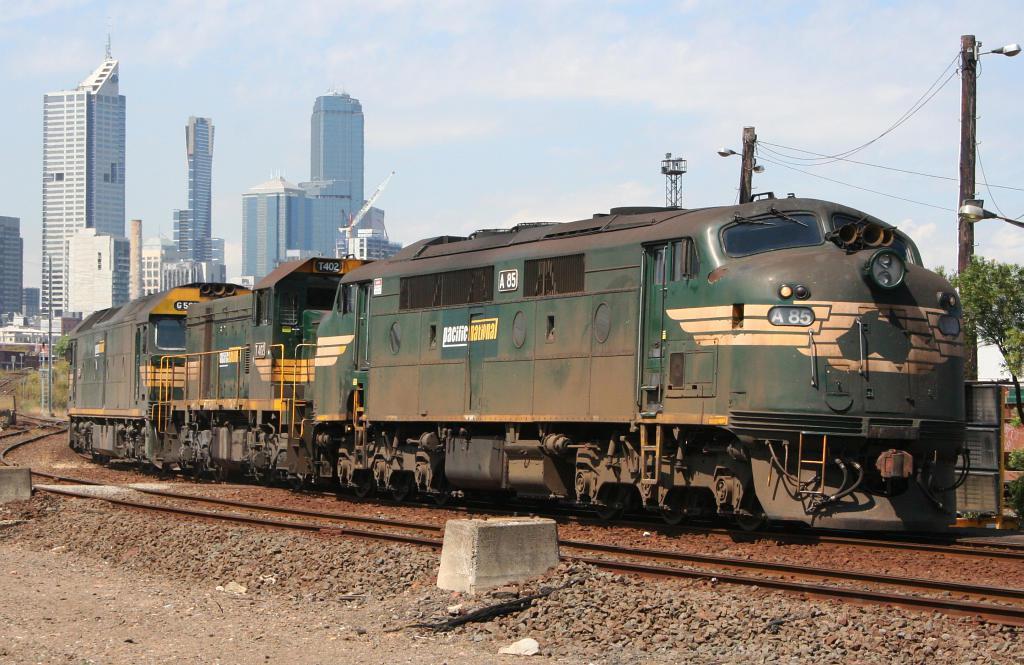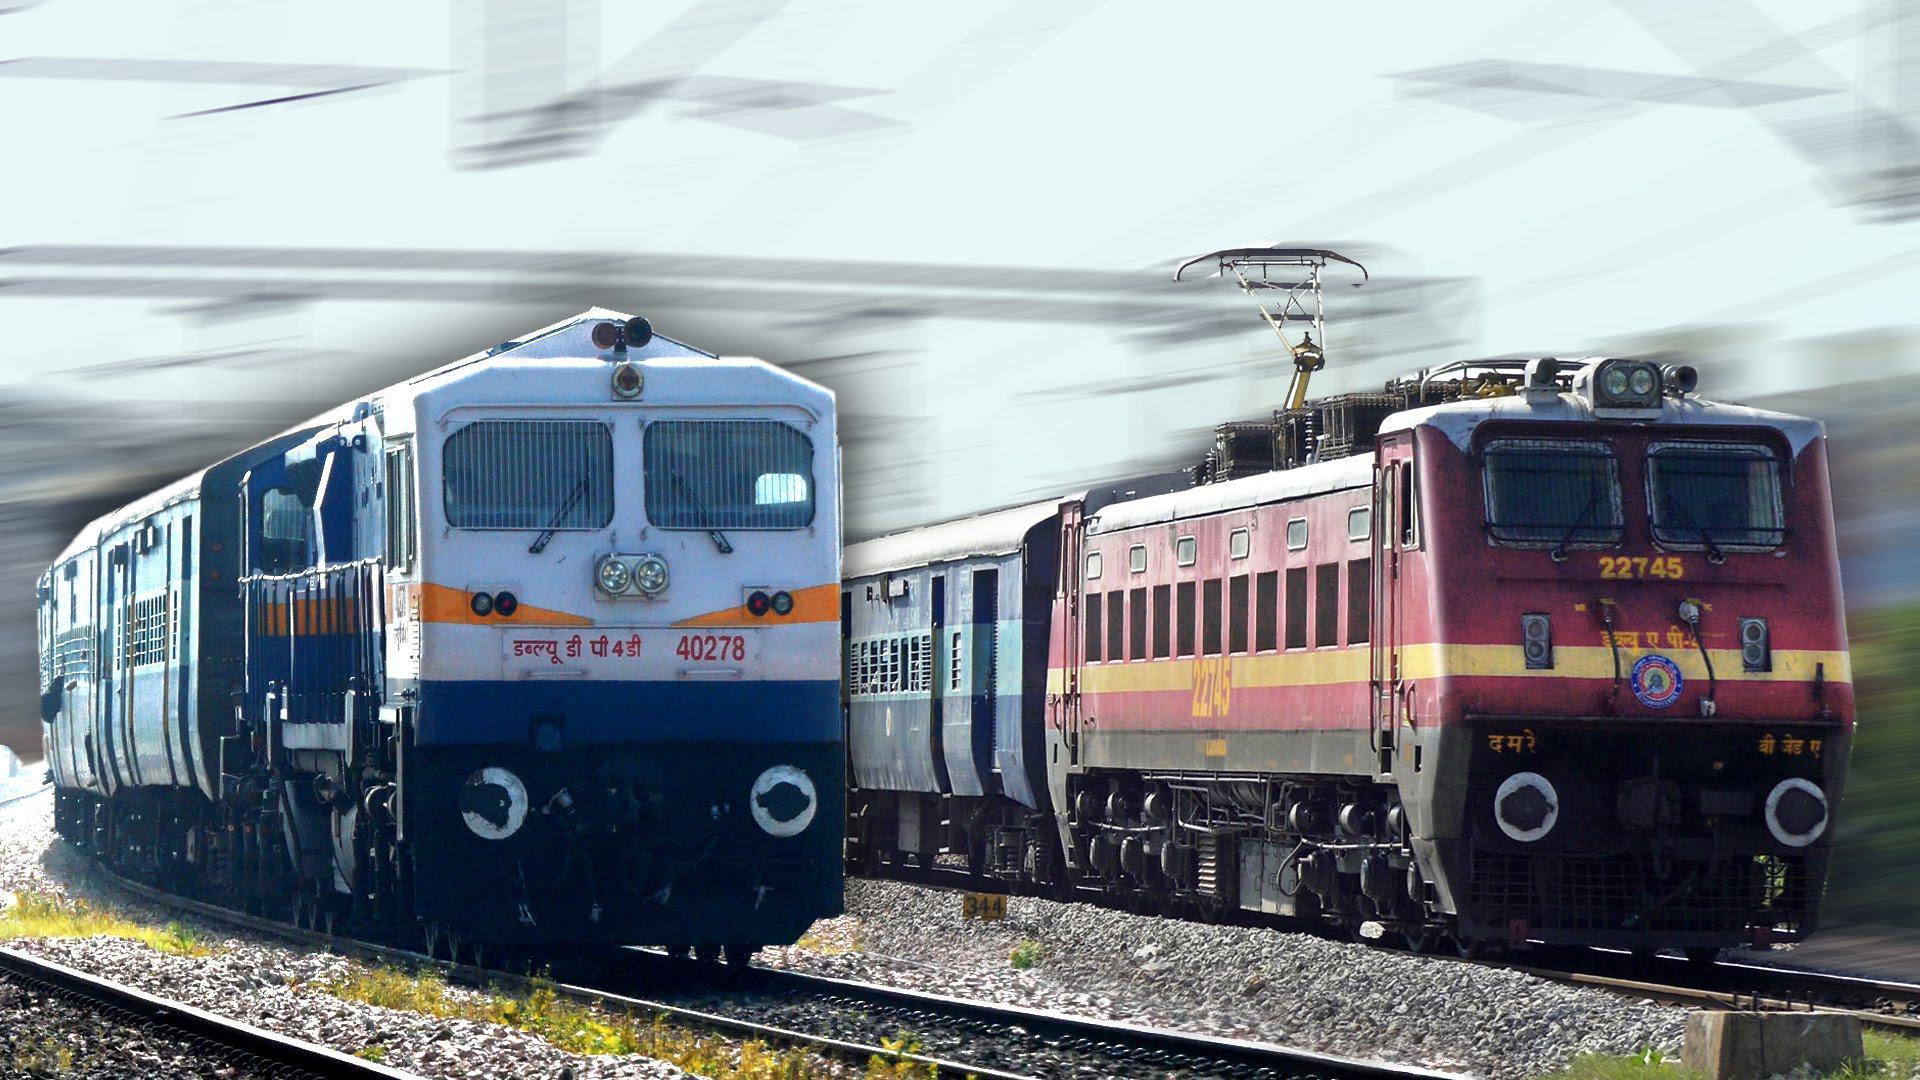The first image is the image on the left, the second image is the image on the right. Evaluate the accuracy of this statement regarding the images: "Thers is at least one ornage train.". Is it true? Answer yes or no. No. 